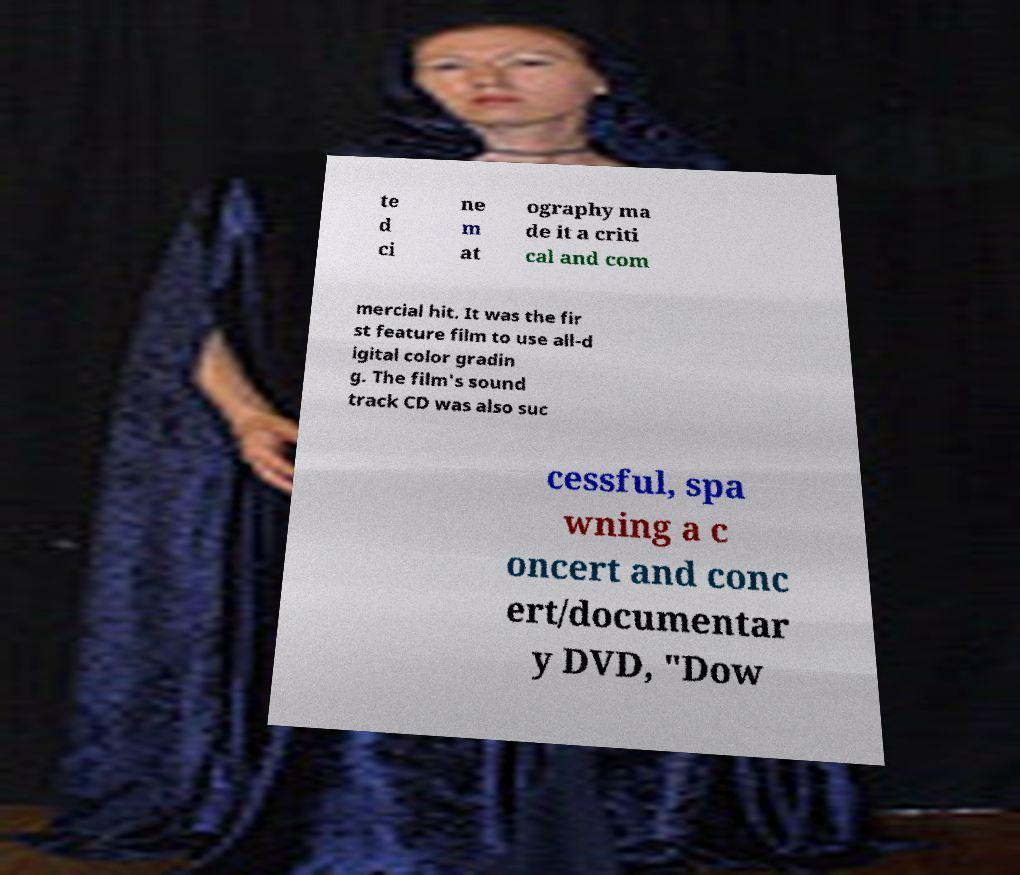Can you read and provide the text displayed in the image?This photo seems to have some interesting text. Can you extract and type it out for me? te d ci ne m at ography ma de it a criti cal and com mercial hit. It was the fir st feature film to use all-d igital color gradin g. The film's sound track CD was also suc cessful, spa wning a c oncert and conc ert/documentar y DVD, "Dow 